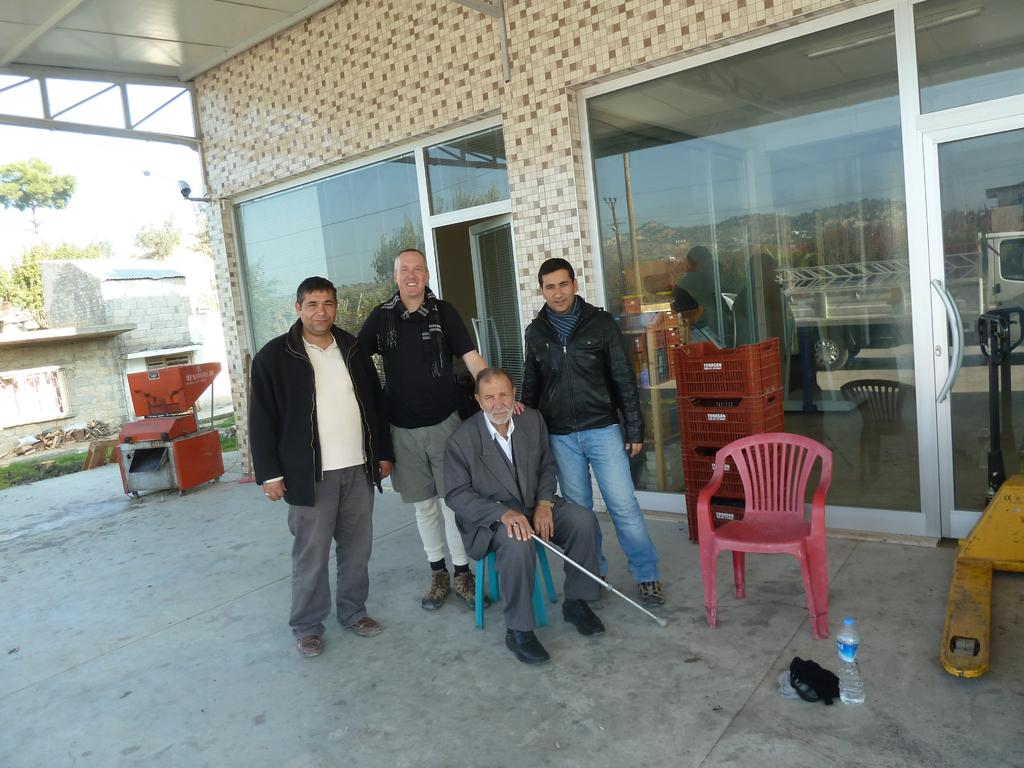How many people are present in the image? There are four people in the image. What can be seen in the background of the image? There is a building, a machine, trees, and the sky visible in the background of the image. What type of fang can be seen in the image? There is no fang present in the image. What subject are the people teaching in the image? The image does not depict any teaching or educational activity. 